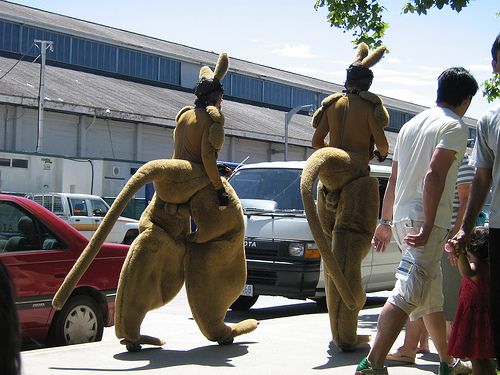<image>
Is there a tail on the car? No. The tail is not positioned on the car. They may be near each other, but the tail is not supported by or resting on top of the car. 